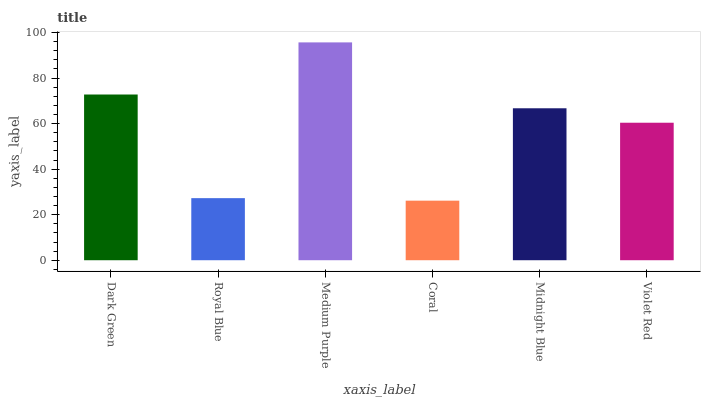Is Coral the minimum?
Answer yes or no. Yes. Is Medium Purple the maximum?
Answer yes or no. Yes. Is Royal Blue the minimum?
Answer yes or no. No. Is Royal Blue the maximum?
Answer yes or no. No. Is Dark Green greater than Royal Blue?
Answer yes or no. Yes. Is Royal Blue less than Dark Green?
Answer yes or no. Yes. Is Royal Blue greater than Dark Green?
Answer yes or no. No. Is Dark Green less than Royal Blue?
Answer yes or no. No. Is Midnight Blue the high median?
Answer yes or no. Yes. Is Violet Red the low median?
Answer yes or no. Yes. Is Dark Green the high median?
Answer yes or no. No. Is Dark Green the low median?
Answer yes or no. No. 